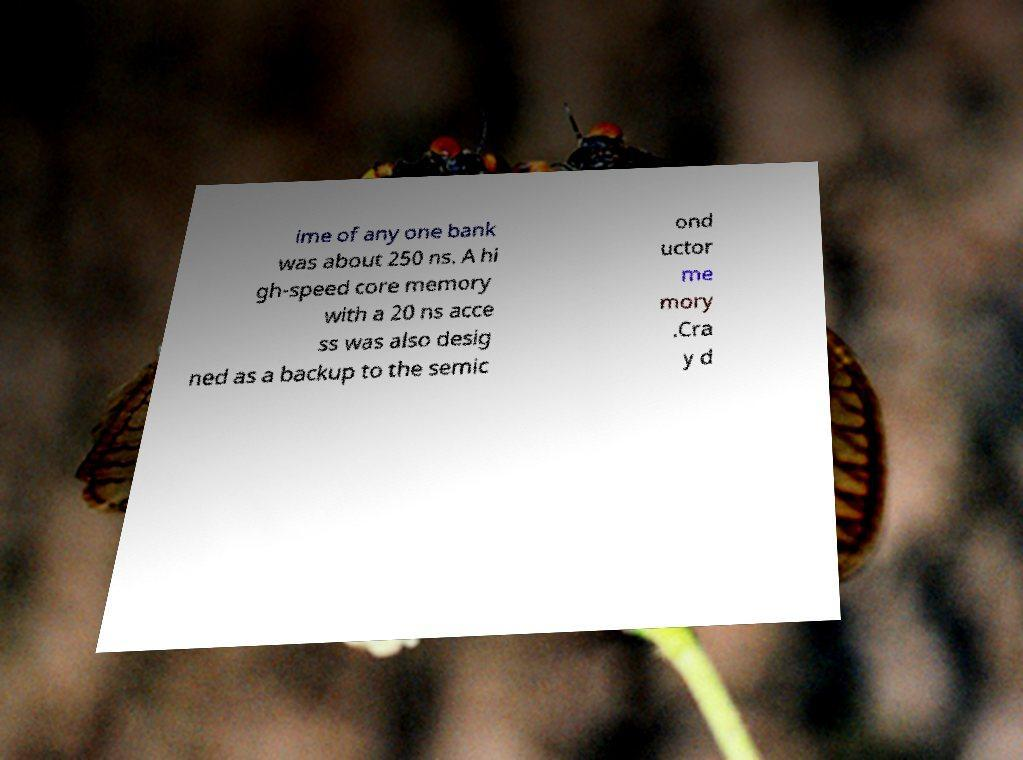There's text embedded in this image that I need extracted. Can you transcribe it verbatim? ime of any one bank was about 250 ns. A hi gh-speed core memory with a 20 ns acce ss was also desig ned as a backup to the semic ond uctor me mory .Cra y d 